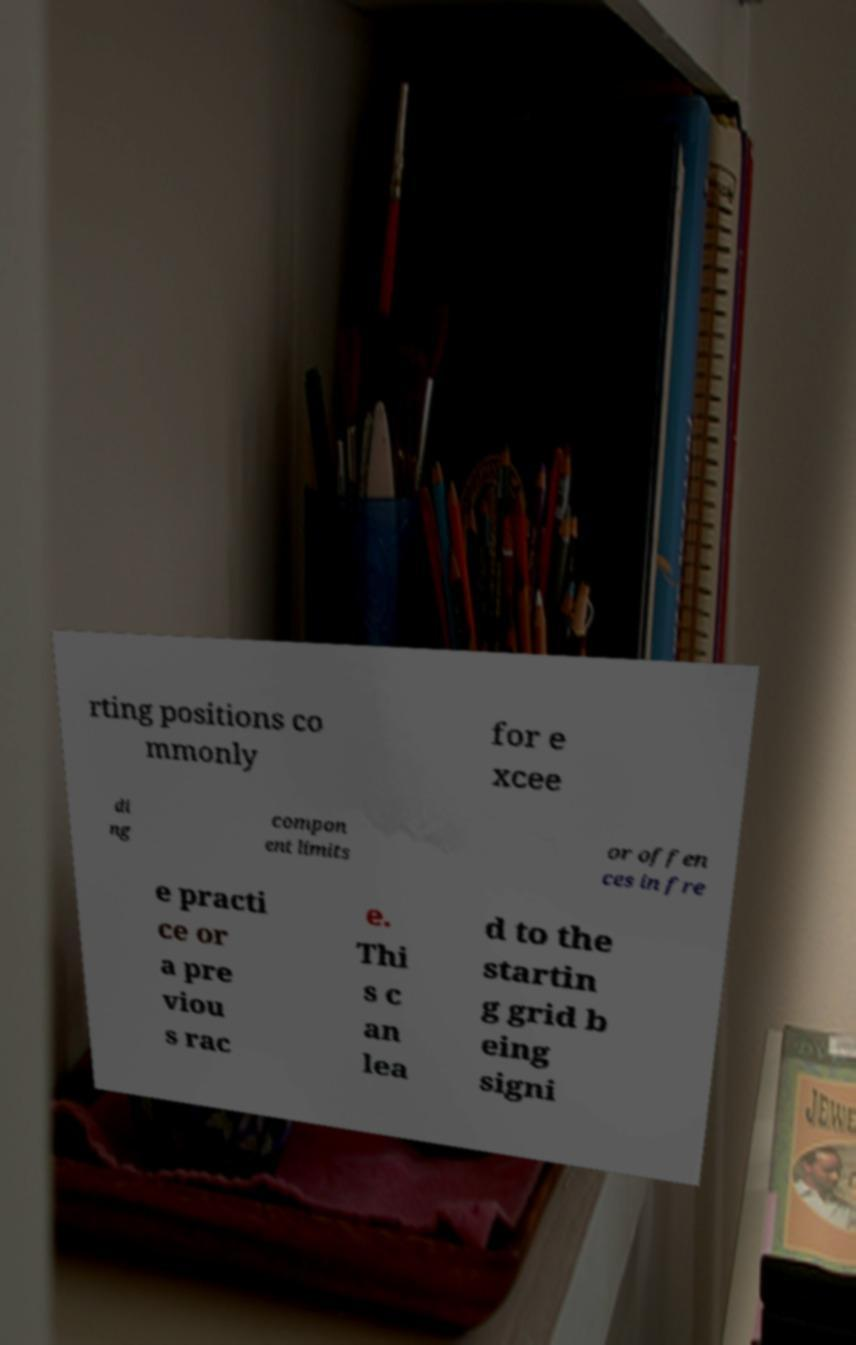What messages or text are displayed in this image? I need them in a readable, typed format. rting positions co mmonly for e xcee di ng compon ent limits or offen ces in fre e practi ce or a pre viou s rac e. Thi s c an lea d to the startin g grid b eing signi 